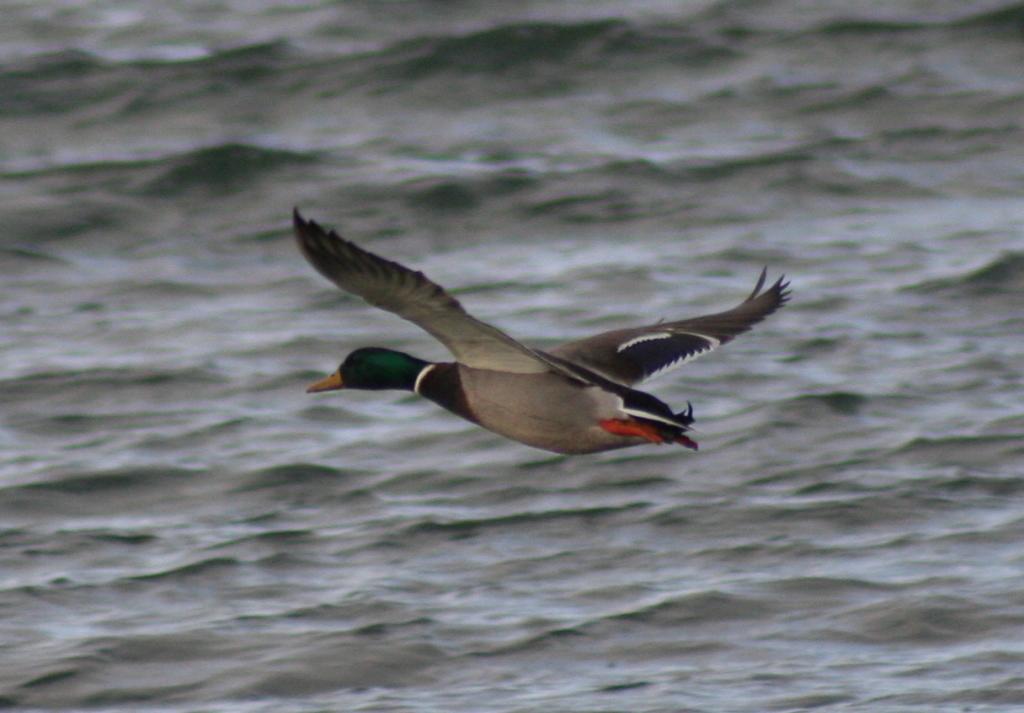Could you give a brief overview of what you see in this image? In the center of the image we can see a bird. In the background there is water. 